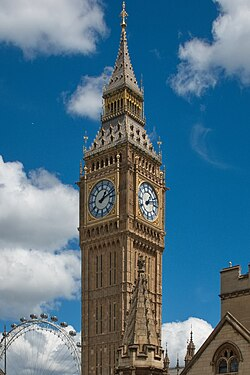What time is displayed on the clock? The clock in the image shows slightly past 10:10. This positioning of the hands is often used in clock imagery as it is visually symmetric and leaves the face of the clock and any branding or design elements clear and unobstructed. 